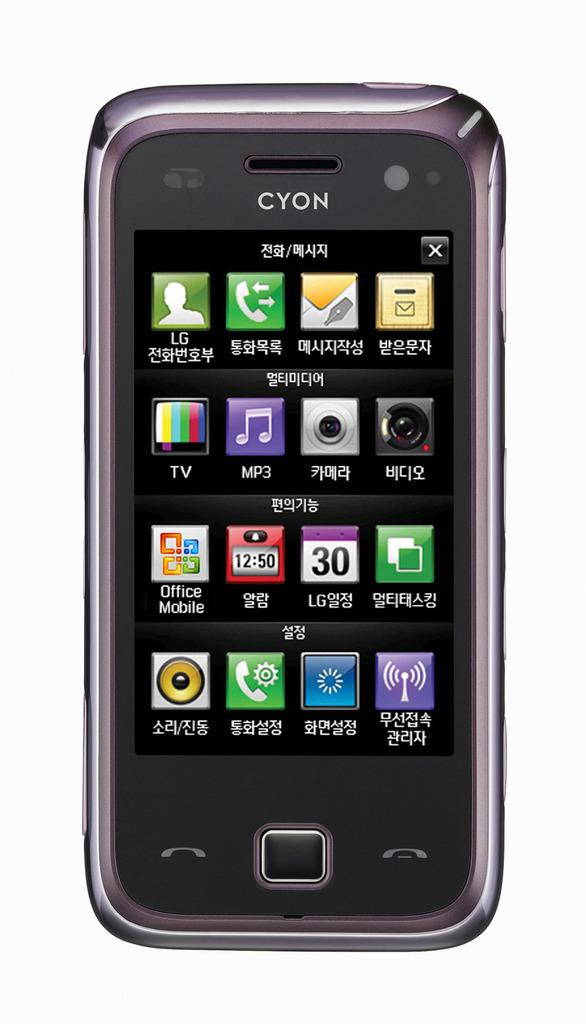What object is located in the center of the image? There is a cell phone in the center of the image. What type of disease is affecting the ground in the image? There is no mention of any disease or ground in the image; it only features a cell phone in the center. 